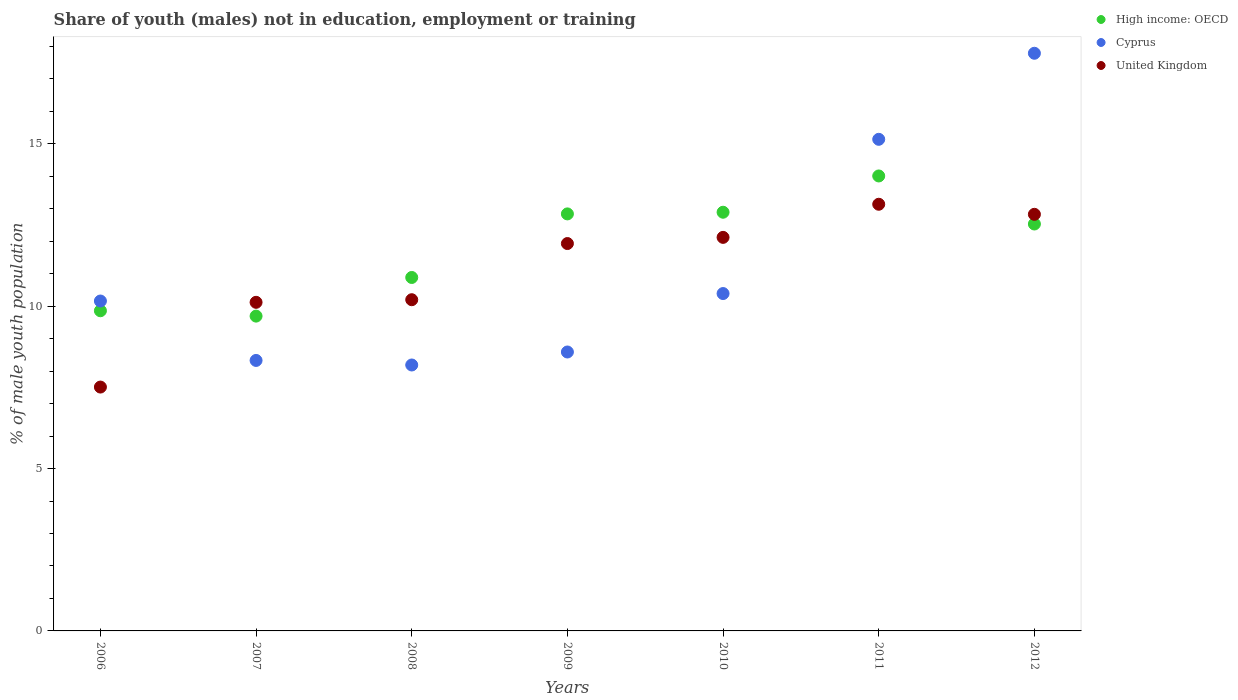What is the percentage of unemployed males population in in Cyprus in 2008?
Your response must be concise. 8.19. Across all years, what is the maximum percentage of unemployed males population in in Cyprus?
Offer a terse response. 17.79. Across all years, what is the minimum percentage of unemployed males population in in United Kingdom?
Offer a terse response. 7.51. In which year was the percentage of unemployed males population in in Cyprus maximum?
Make the answer very short. 2012. What is the total percentage of unemployed males population in in Cyprus in the graph?
Your response must be concise. 78.59. What is the difference between the percentage of unemployed males population in in Cyprus in 2011 and that in 2012?
Ensure brevity in your answer.  -2.65. What is the difference between the percentage of unemployed males population in in Cyprus in 2011 and the percentage of unemployed males population in in United Kingdom in 2008?
Offer a terse response. 4.94. What is the average percentage of unemployed males population in in High income: OECD per year?
Your answer should be compact. 11.82. In the year 2009, what is the difference between the percentage of unemployed males population in in High income: OECD and percentage of unemployed males population in in Cyprus?
Keep it short and to the point. 4.25. In how many years, is the percentage of unemployed males population in in High income: OECD greater than 6 %?
Keep it short and to the point. 7. What is the ratio of the percentage of unemployed males population in in High income: OECD in 2008 to that in 2010?
Ensure brevity in your answer.  0.84. Is the difference between the percentage of unemployed males population in in High income: OECD in 2008 and 2011 greater than the difference between the percentage of unemployed males population in in Cyprus in 2008 and 2011?
Give a very brief answer. Yes. What is the difference between the highest and the second highest percentage of unemployed males population in in High income: OECD?
Offer a terse response. 1.12. What is the difference between the highest and the lowest percentage of unemployed males population in in Cyprus?
Your response must be concise. 9.6. In how many years, is the percentage of unemployed males population in in Cyprus greater than the average percentage of unemployed males population in in Cyprus taken over all years?
Ensure brevity in your answer.  2. Is the sum of the percentage of unemployed males population in in Cyprus in 2009 and 2012 greater than the maximum percentage of unemployed males population in in High income: OECD across all years?
Provide a succinct answer. Yes. Is the percentage of unemployed males population in in Cyprus strictly greater than the percentage of unemployed males population in in United Kingdom over the years?
Give a very brief answer. No. How many years are there in the graph?
Give a very brief answer. 7. Does the graph contain any zero values?
Provide a short and direct response. No. Where does the legend appear in the graph?
Offer a very short reply. Top right. How are the legend labels stacked?
Your response must be concise. Vertical. What is the title of the graph?
Your answer should be compact. Share of youth (males) not in education, employment or training. Does "Ethiopia" appear as one of the legend labels in the graph?
Keep it short and to the point. No. What is the label or title of the X-axis?
Make the answer very short. Years. What is the label or title of the Y-axis?
Ensure brevity in your answer.  % of male youth population. What is the % of male youth population of High income: OECD in 2006?
Make the answer very short. 9.86. What is the % of male youth population of Cyprus in 2006?
Your response must be concise. 10.16. What is the % of male youth population in United Kingdom in 2006?
Provide a succinct answer. 7.51. What is the % of male youth population in High income: OECD in 2007?
Your response must be concise. 9.7. What is the % of male youth population of Cyprus in 2007?
Give a very brief answer. 8.33. What is the % of male youth population of United Kingdom in 2007?
Make the answer very short. 10.12. What is the % of male youth population of High income: OECD in 2008?
Your response must be concise. 10.89. What is the % of male youth population in Cyprus in 2008?
Your response must be concise. 8.19. What is the % of male youth population in United Kingdom in 2008?
Your answer should be compact. 10.2. What is the % of male youth population in High income: OECD in 2009?
Provide a short and direct response. 12.84. What is the % of male youth population in Cyprus in 2009?
Ensure brevity in your answer.  8.59. What is the % of male youth population in United Kingdom in 2009?
Keep it short and to the point. 11.93. What is the % of male youth population of High income: OECD in 2010?
Ensure brevity in your answer.  12.89. What is the % of male youth population in Cyprus in 2010?
Provide a short and direct response. 10.39. What is the % of male youth population of United Kingdom in 2010?
Provide a succinct answer. 12.12. What is the % of male youth population in High income: OECD in 2011?
Ensure brevity in your answer.  14.01. What is the % of male youth population of Cyprus in 2011?
Provide a short and direct response. 15.14. What is the % of male youth population in United Kingdom in 2011?
Make the answer very short. 13.14. What is the % of male youth population of High income: OECD in 2012?
Ensure brevity in your answer.  12.53. What is the % of male youth population in Cyprus in 2012?
Provide a short and direct response. 17.79. What is the % of male youth population in United Kingdom in 2012?
Offer a terse response. 12.83. Across all years, what is the maximum % of male youth population in High income: OECD?
Give a very brief answer. 14.01. Across all years, what is the maximum % of male youth population of Cyprus?
Provide a short and direct response. 17.79. Across all years, what is the maximum % of male youth population in United Kingdom?
Provide a short and direct response. 13.14. Across all years, what is the minimum % of male youth population of High income: OECD?
Keep it short and to the point. 9.7. Across all years, what is the minimum % of male youth population of Cyprus?
Your answer should be compact. 8.19. Across all years, what is the minimum % of male youth population of United Kingdom?
Your response must be concise. 7.51. What is the total % of male youth population of High income: OECD in the graph?
Offer a very short reply. 82.72. What is the total % of male youth population in Cyprus in the graph?
Provide a succinct answer. 78.59. What is the total % of male youth population of United Kingdom in the graph?
Offer a terse response. 77.85. What is the difference between the % of male youth population in High income: OECD in 2006 and that in 2007?
Provide a short and direct response. 0.16. What is the difference between the % of male youth population of Cyprus in 2006 and that in 2007?
Provide a short and direct response. 1.83. What is the difference between the % of male youth population in United Kingdom in 2006 and that in 2007?
Offer a very short reply. -2.61. What is the difference between the % of male youth population of High income: OECD in 2006 and that in 2008?
Your answer should be compact. -1.03. What is the difference between the % of male youth population in Cyprus in 2006 and that in 2008?
Keep it short and to the point. 1.97. What is the difference between the % of male youth population of United Kingdom in 2006 and that in 2008?
Provide a succinct answer. -2.69. What is the difference between the % of male youth population in High income: OECD in 2006 and that in 2009?
Make the answer very short. -2.98. What is the difference between the % of male youth population in Cyprus in 2006 and that in 2009?
Offer a terse response. 1.57. What is the difference between the % of male youth population of United Kingdom in 2006 and that in 2009?
Your answer should be compact. -4.42. What is the difference between the % of male youth population of High income: OECD in 2006 and that in 2010?
Offer a terse response. -3.03. What is the difference between the % of male youth population in Cyprus in 2006 and that in 2010?
Your answer should be compact. -0.23. What is the difference between the % of male youth population in United Kingdom in 2006 and that in 2010?
Make the answer very short. -4.61. What is the difference between the % of male youth population of High income: OECD in 2006 and that in 2011?
Ensure brevity in your answer.  -4.15. What is the difference between the % of male youth population of Cyprus in 2006 and that in 2011?
Offer a very short reply. -4.98. What is the difference between the % of male youth population in United Kingdom in 2006 and that in 2011?
Your answer should be very brief. -5.63. What is the difference between the % of male youth population in High income: OECD in 2006 and that in 2012?
Your answer should be very brief. -2.67. What is the difference between the % of male youth population in Cyprus in 2006 and that in 2012?
Your answer should be very brief. -7.63. What is the difference between the % of male youth population of United Kingdom in 2006 and that in 2012?
Your response must be concise. -5.32. What is the difference between the % of male youth population of High income: OECD in 2007 and that in 2008?
Your response must be concise. -1.19. What is the difference between the % of male youth population in Cyprus in 2007 and that in 2008?
Your answer should be very brief. 0.14. What is the difference between the % of male youth population in United Kingdom in 2007 and that in 2008?
Provide a short and direct response. -0.08. What is the difference between the % of male youth population in High income: OECD in 2007 and that in 2009?
Ensure brevity in your answer.  -3.15. What is the difference between the % of male youth population in Cyprus in 2007 and that in 2009?
Your answer should be compact. -0.26. What is the difference between the % of male youth population of United Kingdom in 2007 and that in 2009?
Make the answer very short. -1.81. What is the difference between the % of male youth population of High income: OECD in 2007 and that in 2010?
Keep it short and to the point. -3.2. What is the difference between the % of male youth population in Cyprus in 2007 and that in 2010?
Offer a terse response. -2.06. What is the difference between the % of male youth population of United Kingdom in 2007 and that in 2010?
Give a very brief answer. -2. What is the difference between the % of male youth population in High income: OECD in 2007 and that in 2011?
Your response must be concise. -4.32. What is the difference between the % of male youth population in Cyprus in 2007 and that in 2011?
Provide a short and direct response. -6.81. What is the difference between the % of male youth population of United Kingdom in 2007 and that in 2011?
Your answer should be very brief. -3.02. What is the difference between the % of male youth population of High income: OECD in 2007 and that in 2012?
Ensure brevity in your answer.  -2.84. What is the difference between the % of male youth population in Cyprus in 2007 and that in 2012?
Your answer should be very brief. -9.46. What is the difference between the % of male youth population in United Kingdom in 2007 and that in 2012?
Offer a terse response. -2.71. What is the difference between the % of male youth population in High income: OECD in 2008 and that in 2009?
Offer a terse response. -1.96. What is the difference between the % of male youth population of United Kingdom in 2008 and that in 2009?
Offer a very short reply. -1.73. What is the difference between the % of male youth population of High income: OECD in 2008 and that in 2010?
Give a very brief answer. -2.01. What is the difference between the % of male youth population of Cyprus in 2008 and that in 2010?
Your answer should be very brief. -2.2. What is the difference between the % of male youth population in United Kingdom in 2008 and that in 2010?
Provide a succinct answer. -1.92. What is the difference between the % of male youth population in High income: OECD in 2008 and that in 2011?
Ensure brevity in your answer.  -3.13. What is the difference between the % of male youth population in Cyprus in 2008 and that in 2011?
Keep it short and to the point. -6.95. What is the difference between the % of male youth population of United Kingdom in 2008 and that in 2011?
Your answer should be compact. -2.94. What is the difference between the % of male youth population in High income: OECD in 2008 and that in 2012?
Make the answer very short. -1.65. What is the difference between the % of male youth population in Cyprus in 2008 and that in 2012?
Give a very brief answer. -9.6. What is the difference between the % of male youth population in United Kingdom in 2008 and that in 2012?
Offer a very short reply. -2.63. What is the difference between the % of male youth population of High income: OECD in 2009 and that in 2010?
Offer a very short reply. -0.05. What is the difference between the % of male youth population of United Kingdom in 2009 and that in 2010?
Provide a succinct answer. -0.19. What is the difference between the % of male youth population in High income: OECD in 2009 and that in 2011?
Give a very brief answer. -1.17. What is the difference between the % of male youth population in Cyprus in 2009 and that in 2011?
Give a very brief answer. -6.55. What is the difference between the % of male youth population in United Kingdom in 2009 and that in 2011?
Offer a very short reply. -1.21. What is the difference between the % of male youth population in High income: OECD in 2009 and that in 2012?
Offer a very short reply. 0.31. What is the difference between the % of male youth population of Cyprus in 2009 and that in 2012?
Keep it short and to the point. -9.2. What is the difference between the % of male youth population of United Kingdom in 2009 and that in 2012?
Provide a succinct answer. -0.9. What is the difference between the % of male youth population in High income: OECD in 2010 and that in 2011?
Provide a short and direct response. -1.12. What is the difference between the % of male youth population in Cyprus in 2010 and that in 2011?
Offer a very short reply. -4.75. What is the difference between the % of male youth population of United Kingdom in 2010 and that in 2011?
Provide a short and direct response. -1.02. What is the difference between the % of male youth population of High income: OECD in 2010 and that in 2012?
Your response must be concise. 0.36. What is the difference between the % of male youth population in United Kingdom in 2010 and that in 2012?
Provide a succinct answer. -0.71. What is the difference between the % of male youth population of High income: OECD in 2011 and that in 2012?
Provide a short and direct response. 1.48. What is the difference between the % of male youth population of Cyprus in 2011 and that in 2012?
Offer a very short reply. -2.65. What is the difference between the % of male youth population of United Kingdom in 2011 and that in 2012?
Keep it short and to the point. 0.31. What is the difference between the % of male youth population of High income: OECD in 2006 and the % of male youth population of Cyprus in 2007?
Keep it short and to the point. 1.53. What is the difference between the % of male youth population of High income: OECD in 2006 and the % of male youth population of United Kingdom in 2007?
Your answer should be compact. -0.26. What is the difference between the % of male youth population in Cyprus in 2006 and the % of male youth population in United Kingdom in 2007?
Provide a short and direct response. 0.04. What is the difference between the % of male youth population in High income: OECD in 2006 and the % of male youth population in Cyprus in 2008?
Keep it short and to the point. 1.67. What is the difference between the % of male youth population in High income: OECD in 2006 and the % of male youth population in United Kingdom in 2008?
Ensure brevity in your answer.  -0.34. What is the difference between the % of male youth population in Cyprus in 2006 and the % of male youth population in United Kingdom in 2008?
Your answer should be compact. -0.04. What is the difference between the % of male youth population in High income: OECD in 2006 and the % of male youth population in Cyprus in 2009?
Provide a short and direct response. 1.27. What is the difference between the % of male youth population of High income: OECD in 2006 and the % of male youth population of United Kingdom in 2009?
Provide a short and direct response. -2.07. What is the difference between the % of male youth population of Cyprus in 2006 and the % of male youth population of United Kingdom in 2009?
Ensure brevity in your answer.  -1.77. What is the difference between the % of male youth population of High income: OECD in 2006 and the % of male youth population of Cyprus in 2010?
Your answer should be compact. -0.53. What is the difference between the % of male youth population of High income: OECD in 2006 and the % of male youth population of United Kingdom in 2010?
Provide a short and direct response. -2.26. What is the difference between the % of male youth population in Cyprus in 2006 and the % of male youth population in United Kingdom in 2010?
Make the answer very short. -1.96. What is the difference between the % of male youth population in High income: OECD in 2006 and the % of male youth population in Cyprus in 2011?
Provide a short and direct response. -5.28. What is the difference between the % of male youth population in High income: OECD in 2006 and the % of male youth population in United Kingdom in 2011?
Make the answer very short. -3.28. What is the difference between the % of male youth population of Cyprus in 2006 and the % of male youth population of United Kingdom in 2011?
Offer a very short reply. -2.98. What is the difference between the % of male youth population of High income: OECD in 2006 and the % of male youth population of Cyprus in 2012?
Provide a succinct answer. -7.93. What is the difference between the % of male youth population in High income: OECD in 2006 and the % of male youth population in United Kingdom in 2012?
Your answer should be compact. -2.97. What is the difference between the % of male youth population of Cyprus in 2006 and the % of male youth population of United Kingdom in 2012?
Provide a succinct answer. -2.67. What is the difference between the % of male youth population of High income: OECD in 2007 and the % of male youth population of Cyprus in 2008?
Ensure brevity in your answer.  1.51. What is the difference between the % of male youth population in High income: OECD in 2007 and the % of male youth population in United Kingdom in 2008?
Provide a succinct answer. -0.5. What is the difference between the % of male youth population in Cyprus in 2007 and the % of male youth population in United Kingdom in 2008?
Ensure brevity in your answer.  -1.87. What is the difference between the % of male youth population in High income: OECD in 2007 and the % of male youth population in Cyprus in 2009?
Provide a short and direct response. 1.11. What is the difference between the % of male youth population in High income: OECD in 2007 and the % of male youth population in United Kingdom in 2009?
Keep it short and to the point. -2.23. What is the difference between the % of male youth population in High income: OECD in 2007 and the % of male youth population in Cyprus in 2010?
Your answer should be very brief. -0.69. What is the difference between the % of male youth population of High income: OECD in 2007 and the % of male youth population of United Kingdom in 2010?
Offer a very short reply. -2.42. What is the difference between the % of male youth population of Cyprus in 2007 and the % of male youth population of United Kingdom in 2010?
Provide a short and direct response. -3.79. What is the difference between the % of male youth population in High income: OECD in 2007 and the % of male youth population in Cyprus in 2011?
Offer a terse response. -5.44. What is the difference between the % of male youth population of High income: OECD in 2007 and the % of male youth population of United Kingdom in 2011?
Offer a terse response. -3.44. What is the difference between the % of male youth population of Cyprus in 2007 and the % of male youth population of United Kingdom in 2011?
Your answer should be very brief. -4.81. What is the difference between the % of male youth population in High income: OECD in 2007 and the % of male youth population in Cyprus in 2012?
Your answer should be very brief. -8.09. What is the difference between the % of male youth population in High income: OECD in 2007 and the % of male youth population in United Kingdom in 2012?
Your response must be concise. -3.13. What is the difference between the % of male youth population in Cyprus in 2007 and the % of male youth population in United Kingdom in 2012?
Your answer should be very brief. -4.5. What is the difference between the % of male youth population of High income: OECD in 2008 and the % of male youth population of Cyprus in 2009?
Keep it short and to the point. 2.3. What is the difference between the % of male youth population in High income: OECD in 2008 and the % of male youth population in United Kingdom in 2009?
Keep it short and to the point. -1.04. What is the difference between the % of male youth population in Cyprus in 2008 and the % of male youth population in United Kingdom in 2009?
Give a very brief answer. -3.74. What is the difference between the % of male youth population in High income: OECD in 2008 and the % of male youth population in Cyprus in 2010?
Offer a very short reply. 0.5. What is the difference between the % of male youth population of High income: OECD in 2008 and the % of male youth population of United Kingdom in 2010?
Provide a succinct answer. -1.23. What is the difference between the % of male youth population in Cyprus in 2008 and the % of male youth population in United Kingdom in 2010?
Keep it short and to the point. -3.93. What is the difference between the % of male youth population of High income: OECD in 2008 and the % of male youth population of Cyprus in 2011?
Your answer should be very brief. -4.25. What is the difference between the % of male youth population of High income: OECD in 2008 and the % of male youth population of United Kingdom in 2011?
Offer a terse response. -2.25. What is the difference between the % of male youth population in Cyprus in 2008 and the % of male youth population in United Kingdom in 2011?
Offer a very short reply. -4.95. What is the difference between the % of male youth population in High income: OECD in 2008 and the % of male youth population in Cyprus in 2012?
Offer a terse response. -6.9. What is the difference between the % of male youth population of High income: OECD in 2008 and the % of male youth population of United Kingdom in 2012?
Offer a terse response. -1.94. What is the difference between the % of male youth population of Cyprus in 2008 and the % of male youth population of United Kingdom in 2012?
Ensure brevity in your answer.  -4.64. What is the difference between the % of male youth population in High income: OECD in 2009 and the % of male youth population in Cyprus in 2010?
Keep it short and to the point. 2.45. What is the difference between the % of male youth population in High income: OECD in 2009 and the % of male youth population in United Kingdom in 2010?
Offer a terse response. 0.72. What is the difference between the % of male youth population of Cyprus in 2009 and the % of male youth population of United Kingdom in 2010?
Keep it short and to the point. -3.53. What is the difference between the % of male youth population of High income: OECD in 2009 and the % of male youth population of Cyprus in 2011?
Give a very brief answer. -2.3. What is the difference between the % of male youth population of High income: OECD in 2009 and the % of male youth population of United Kingdom in 2011?
Offer a terse response. -0.3. What is the difference between the % of male youth population in Cyprus in 2009 and the % of male youth population in United Kingdom in 2011?
Provide a succinct answer. -4.55. What is the difference between the % of male youth population in High income: OECD in 2009 and the % of male youth population in Cyprus in 2012?
Give a very brief answer. -4.95. What is the difference between the % of male youth population of High income: OECD in 2009 and the % of male youth population of United Kingdom in 2012?
Keep it short and to the point. 0.01. What is the difference between the % of male youth population of Cyprus in 2009 and the % of male youth population of United Kingdom in 2012?
Provide a short and direct response. -4.24. What is the difference between the % of male youth population of High income: OECD in 2010 and the % of male youth population of Cyprus in 2011?
Provide a short and direct response. -2.25. What is the difference between the % of male youth population in High income: OECD in 2010 and the % of male youth population in United Kingdom in 2011?
Offer a very short reply. -0.25. What is the difference between the % of male youth population in Cyprus in 2010 and the % of male youth population in United Kingdom in 2011?
Your response must be concise. -2.75. What is the difference between the % of male youth population in High income: OECD in 2010 and the % of male youth population in Cyprus in 2012?
Make the answer very short. -4.9. What is the difference between the % of male youth population of High income: OECD in 2010 and the % of male youth population of United Kingdom in 2012?
Give a very brief answer. 0.06. What is the difference between the % of male youth population of Cyprus in 2010 and the % of male youth population of United Kingdom in 2012?
Provide a short and direct response. -2.44. What is the difference between the % of male youth population of High income: OECD in 2011 and the % of male youth population of Cyprus in 2012?
Your answer should be very brief. -3.78. What is the difference between the % of male youth population in High income: OECD in 2011 and the % of male youth population in United Kingdom in 2012?
Make the answer very short. 1.18. What is the difference between the % of male youth population in Cyprus in 2011 and the % of male youth population in United Kingdom in 2012?
Offer a terse response. 2.31. What is the average % of male youth population in High income: OECD per year?
Your response must be concise. 11.82. What is the average % of male youth population in Cyprus per year?
Your answer should be compact. 11.23. What is the average % of male youth population in United Kingdom per year?
Offer a terse response. 11.12. In the year 2006, what is the difference between the % of male youth population of High income: OECD and % of male youth population of Cyprus?
Give a very brief answer. -0.3. In the year 2006, what is the difference between the % of male youth population in High income: OECD and % of male youth population in United Kingdom?
Your response must be concise. 2.35. In the year 2006, what is the difference between the % of male youth population of Cyprus and % of male youth population of United Kingdom?
Make the answer very short. 2.65. In the year 2007, what is the difference between the % of male youth population in High income: OECD and % of male youth population in Cyprus?
Your answer should be compact. 1.37. In the year 2007, what is the difference between the % of male youth population in High income: OECD and % of male youth population in United Kingdom?
Your answer should be very brief. -0.42. In the year 2007, what is the difference between the % of male youth population of Cyprus and % of male youth population of United Kingdom?
Ensure brevity in your answer.  -1.79. In the year 2008, what is the difference between the % of male youth population of High income: OECD and % of male youth population of Cyprus?
Your answer should be compact. 2.7. In the year 2008, what is the difference between the % of male youth population in High income: OECD and % of male youth population in United Kingdom?
Provide a succinct answer. 0.69. In the year 2008, what is the difference between the % of male youth population in Cyprus and % of male youth population in United Kingdom?
Your answer should be very brief. -2.01. In the year 2009, what is the difference between the % of male youth population of High income: OECD and % of male youth population of Cyprus?
Keep it short and to the point. 4.25. In the year 2009, what is the difference between the % of male youth population of High income: OECD and % of male youth population of United Kingdom?
Your response must be concise. 0.91. In the year 2009, what is the difference between the % of male youth population of Cyprus and % of male youth population of United Kingdom?
Offer a very short reply. -3.34. In the year 2010, what is the difference between the % of male youth population in High income: OECD and % of male youth population in Cyprus?
Offer a very short reply. 2.5. In the year 2010, what is the difference between the % of male youth population in High income: OECD and % of male youth population in United Kingdom?
Make the answer very short. 0.77. In the year 2010, what is the difference between the % of male youth population in Cyprus and % of male youth population in United Kingdom?
Your answer should be very brief. -1.73. In the year 2011, what is the difference between the % of male youth population of High income: OECD and % of male youth population of Cyprus?
Ensure brevity in your answer.  -1.13. In the year 2011, what is the difference between the % of male youth population in High income: OECD and % of male youth population in United Kingdom?
Your response must be concise. 0.87. In the year 2011, what is the difference between the % of male youth population of Cyprus and % of male youth population of United Kingdom?
Make the answer very short. 2. In the year 2012, what is the difference between the % of male youth population of High income: OECD and % of male youth population of Cyprus?
Give a very brief answer. -5.26. In the year 2012, what is the difference between the % of male youth population in High income: OECD and % of male youth population in United Kingdom?
Make the answer very short. -0.3. In the year 2012, what is the difference between the % of male youth population of Cyprus and % of male youth population of United Kingdom?
Offer a terse response. 4.96. What is the ratio of the % of male youth population of Cyprus in 2006 to that in 2007?
Provide a succinct answer. 1.22. What is the ratio of the % of male youth population in United Kingdom in 2006 to that in 2007?
Make the answer very short. 0.74. What is the ratio of the % of male youth population of High income: OECD in 2006 to that in 2008?
Offer a terse response. 0.91. What is the ratio of the % of male youth population in Cyprus in 2006 to that in 2008?
Offer a very short reply. 1.24. What is the ratio of the % of male youth population in United Kingdom in 2006 to that in 2008?
Ensure brevity in your answer.  0.74. What is the ratio of the % of male youth population in High income: OECD in 2006 to that in 2009?
Give a very brief answer. 0.77. What is the ratio of the % of male youth population in Cyprus in 2006 to that in 2009?
Your response must be concise. 1.18. What is the ratio of the % of male youth population of United Kingdom in 2006 to that in 2009?
Keep it short and to the point. 0.63. What is the ratio of the % of male youth population in High income: OECD in 2006 to that in 2010?
Offer a terse response. 0.76. What is the ratio of the % of male youth population of Cyprus in 2006 to that in 2010?
Your response must be concise. 0.98. What is the ratio of the % of male youth population in United Kingdom in 2006 to that in 2010?
Offer a very short reply. 0.62. What is the ratio of the % of male youth population in High income: OECD in 2006 to that in 2011?
Make the answer very short. 0.7. What is the ratio of the % of male youth population in Cyprus in 2006 to that in 2011?
Make the answer very short. 0.67. What is the ratio of the % of male youth population of United Kingdom in 2006 to that in 2011?
Your answer should be compact. 0.57. What is the ratio of the % of male youth population in High income: OECD in 2006 to that in 2012?
Ensure brevity in your answer.  0.79. What is the ratio of the % of male youth population of Cyprus in 2006 to that in 2012?
Provide a short and direct response. 0.57. What is the ratio of the % of male youth population in United Kingdom in 2006 to that in 2012?
Your answer should be very brief. 0.59. What is the ratio of the % of male youth population in High income: OECD in 2007 to that in 2008?
Make the answer very short. 0.89. What is the ratio of the % of male youth population of Cyprus in 2007 to that in 2008?
Ensure brevity in your answer.  1.02. What is the ratio of the % of male youth population of High income: OECD in 2007 to that in 2009?
Provide a succinct answer. 0.75. What is the ratio of the % of male youth population in Cyprus in 2007 to that in 2009?
Provide a succinct answer. 0.97. What is the ratio of the % of male youth population in United Kingdom in 2007 to that in 2009?
Offer a very short reply. 0.85. What is the ratio of the % of male youth population in High income: OECD in 2007 to that in 2010?
Provide a succinct answer. 0.75. What is the ratio of the % of male youth population in Cyprus in 2007 to that in 2010?
Keep it short and to the point. 0.8. What is the ratio of the % of male youth population of United Kingdom in 2007 to that in 2010?
Provide a short and direct response. 0.83. What is the ratio of the % of male youth population of High income: OECD in 2007 to that in 2011?
Your response must be concise. 0.69. What is the ratio of the % of male youth population in Cyprus in 2007 to that in 2011?
Provide a short and direct response. 0.55. What is the ratio of the % of male youth population in United Kingdom in 2007 to that in 2011?
Your response must be concise. 0.77. What is the ratio of the % of male youth population of High income: OECD in 2007 to that in 2012?
Your answer should be compact. 0.77. What is the ratio of the % of male youth population in Cyprus in 2007 to that in 2012?
Offer a very short reply. 0.47. What is the ratio of the % of male youth population of United Kingdom in 2007 to that in 2012?
Provide a short and direct response. 0.79. What is the ratio of the % of male youth population in High income: OECD in 2008 to that in 2009?
Your response must be concise. 0.85. What is the ratio of the % of male youth population in Cyprus in 2008 to that in 2009?
Offer a terse response. 0.95. What is the ratio of the % of male youth population of United Kingdom in 2008 to that in 2009?
Provide a succinct answer. 0.85. What is the ratio of the % of male youth population in High income: OECD in 2008 to that in 2010?
Provide a succinct answer. 0.84. What is the ratio of the % of male youth population of Cyprus in 2008 to that in 2010?
Keep it short and to the point. 0.79. What is the ratio of the % of male youth population of United Kingdom in 2008 to that in 2010?
Keep it short and to the point. 0.84. What is the ratio of the % of male youth population in High income: OECD in 2008 to that in 2011?
Provide a short and direct response. 0.78. What is the ratio of the % of male youth population of Cyprus in 2008 to that in 2011?
Provide a succinct answer. 0.54. What is the ratio of the % of male youth population of United Kingdom in 2008 to that in 2011?
Your response must be concise. 0.78. What is the ratio of the % of male youth population of High income: OECD in 2008 to that in 2012?
Keep it short and to the point. 0.87. What is the ratio of the % of male youth population of Cyprus in 2008 to that in 2012?
Provide a short and direct response. 0.46. What is the ratio of the % of male youth population of United Kingdom in 2008 to that in 2012?
Your answer should be compact. 0.8. What is the ratio of the % of male youth population of High income: OECD in 2009 to that in 2010?
Make the answer very short. 1. What is the ratio of the % of male youth population of Cyprus in 2009 to that in 2010?
Make the answer very short. 0.83. What is the ratio of the % of male youth population of United Kingdom in 2009 to that in 2010?
Keep it short and to the point. 0.98. What is the ratio of the % of male youth population of High income: OECD in 2009 to that in 2011?
Make the answer very short. 0.92. What is the ratio of the % of male youth population in Cyprus in 2009 to that in 2011?
Provide a short and direct response. 0.57. What is the ratio of the % of male youth population of United Kingdom in 2009 to that in 2011?
Offer a very short reply. 0.91. What is the ratio of the % of male youth population of High income: OECD in 2009 to that in 2012?
Offer a very short reply. 1.02. What is the ratio of the % of male youth population in Cyprus in 2009 to that in 2012?
Your response must be concise. 0.48. What is the ratio of the % of male youth population in United Kingdom in 2009 to that in 2012?
Your answer should be compact. 0.93. What is the ratio of the % of male youth population of High income: OECD in 2010 to that in 2011?
Provide a short and direct response. 0.92. What is the ratio of the % of male youth population of Cyprus in 2010 to that in 2011?
Provide a short and direct response. 0.69. What is the ratio of the % of male youth population in United Kingdom in 2010 to that in 2011?
Offer a very short reply. 0.92. What is the ratio of the % of male youth population of High income: OECD in 2010 to that in 2012?
Ensure brevity in your answer.  1.03. What is the ratio of the % of male youth population of Cyprus in 2010 to that in 2012?
Provide a short and direct response. 0.58. What is the ratio of the % of male youth population in United Kingdom in 2010 to that in 2012?
Keep it short and to the point. 0.94. What is the ratio of the % of male youth population in High income: OECD in 2011 to that in 2012?
Offer a very short reply. 1.12. What is the ratio of the % of male youth population of Cyprus in 2011 to that in 2012?
Keep it short and to the point. 0.85. What is the ratio of the % of male youth population in United Kingdom in 2011 to that in 2012?
Your answer should be compact. 1.02. What is the difference between the highest and the second highest % of male youth population of High income: OECD?
Your response must be concise. 1.12. What is the difference between the highest and the second highest % of male youth population of Cyprus?
Provide a succinct answer. 2.65. What is the difference between the highest and the second highest % of male youth population of United Kingdom?
Keep it short and to the point. 0.31. What is the difference between the highest and the lowest % of male youth population of High income: OECD?
Your response must be concise. 4.32. What is the difference between the highest and the lowest % of male youth population in Cyprus?
Offer a very short reply. 9.6. What is the difference between the highest and the lowest % of male youth population of United Kingdom?
Your answer should be very brief. 5.63. 